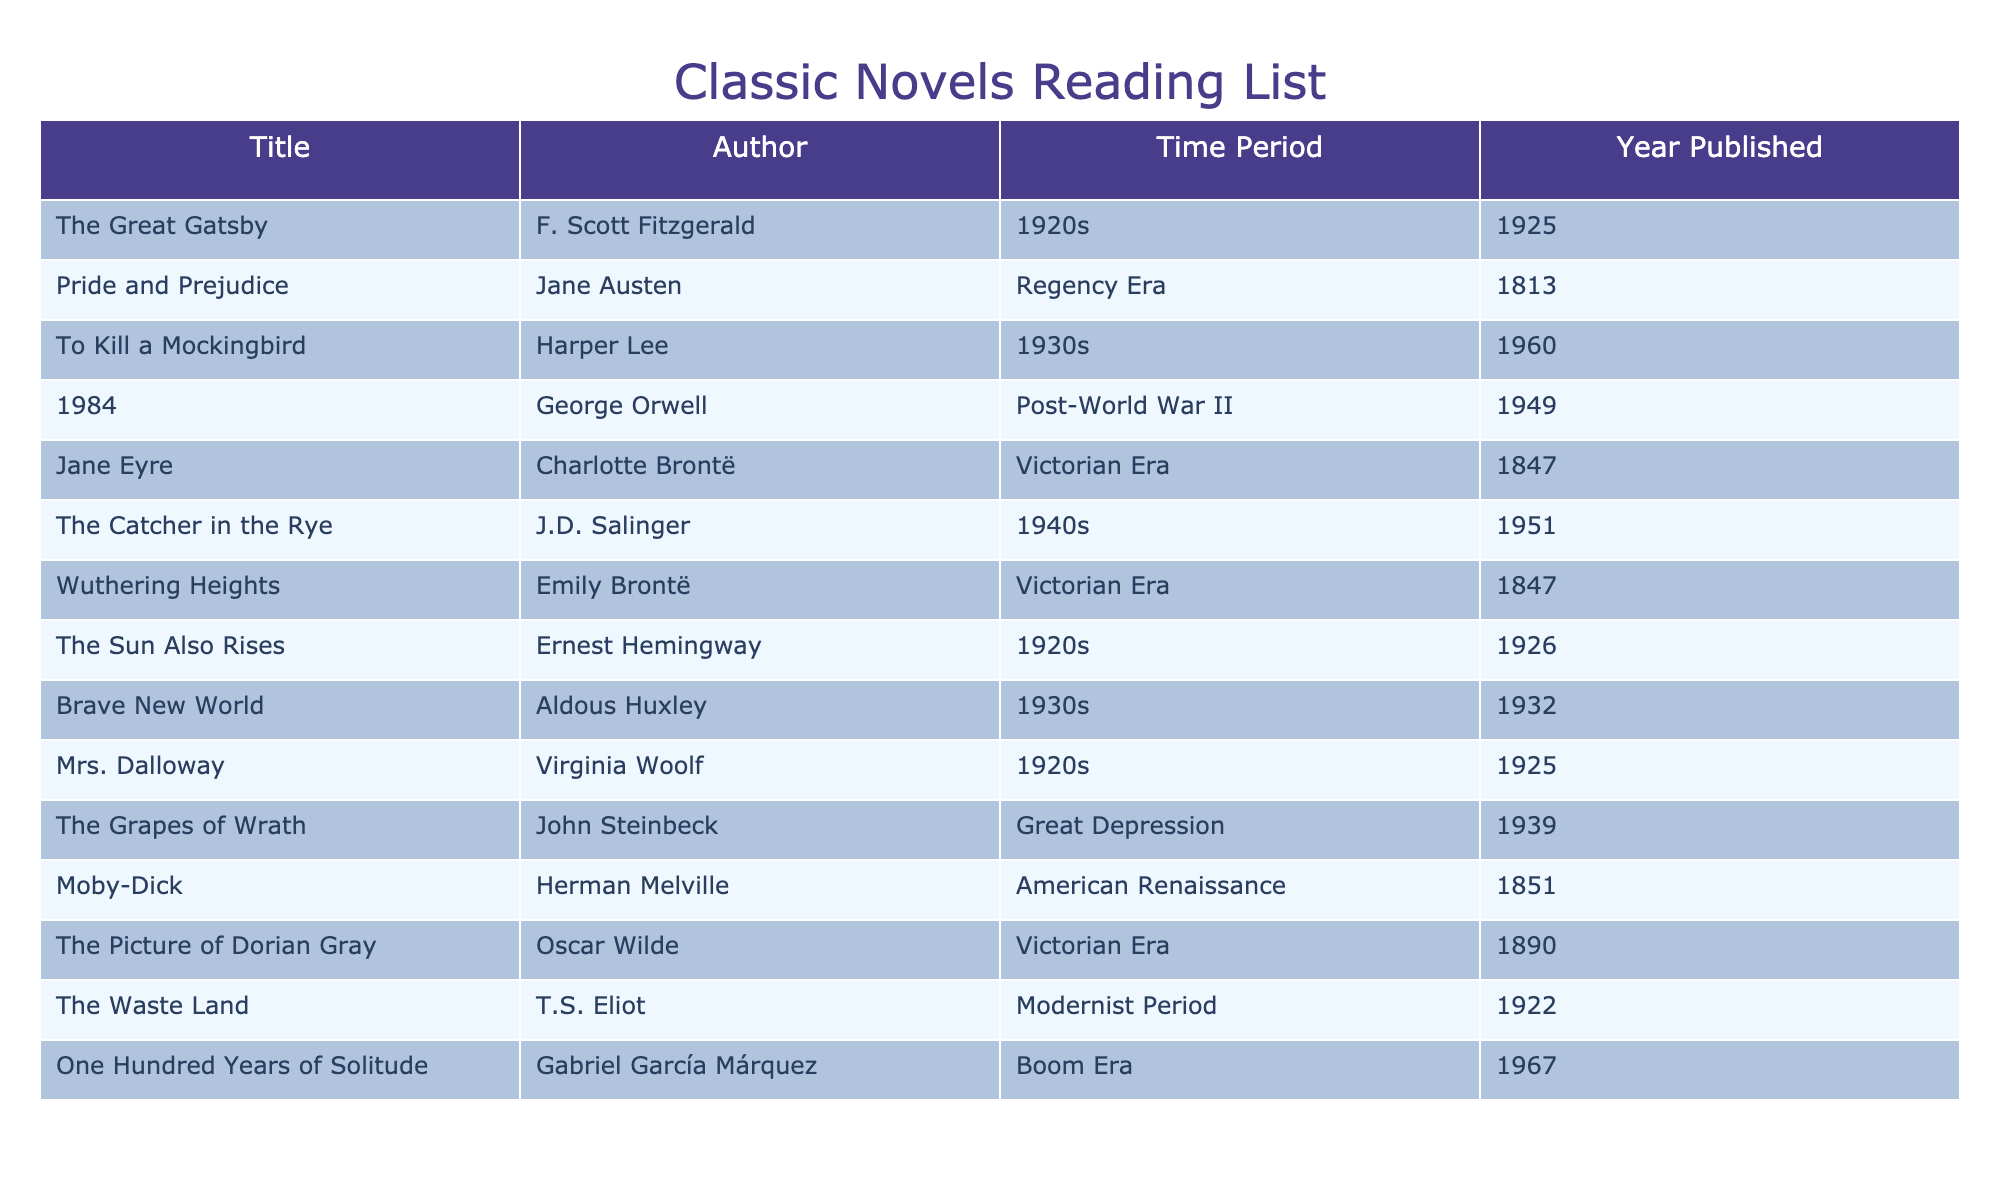What novels were published in the 1920s? The table lists three novels published in the 1920s: "The Great Gatsby" by F. Scott Fitzgerald in 1925, "The Sun Also Rises" by Ernest Hemingway in 1926, and "Mrs. Dalloway" by Virginia Woolf in 1925.
Answer: The Great Gatsby, The Sun Also Rises, Mrs. Dalloway Which author wrote "Pride and Prejudice"? The table indicates that "Pride and Prejudice" is written by Jane Austen.
Answer: Jane Austen Was "1984" published before "To Kill a Mockingbird"? The publication year of "1984" is 1949 and "To Kill a Mockingbird" in 1960; since 1949 is earlier than 1960, the statement is true.
Answer: Yes How many novels in the table are from the Victorian Era? The table lists "Jane Eyre," "Wuthering Heights," and "The Picture of Dorian Gray," so there are three novels from the Victorian Era.
Answer: 3 Which novel published in the 1930s has the earliest publication year? From the table, "Brave New World" was published in 1932, and "To Kill a Mockingbird" was published in 1960. Therefore, "Brave New World" has the earliest year of 1932.
Answer: Brave New World What is the time period of "The Grapes of Wrath"? The table states that "The Grapes of Wrath" by John Steinbeck is from the Great Depression time period.
Answer: Great Depression How many novels are attributed to the Modernist Period? From the table, only "The Waste Land" by T.S. Eliot is listed under the Modernist Period, thus only one novel is attributed to that period.
Answer: 1 Which author published the most novels in the table? The table lists unique novels by different authors without repetitions, so every author published one novel, but there are two by both Brontë sisters (Charlotte and Emily). Thus, the authors with the most novels are those two with each having one.
Answer: 2 Is "One Hundred Years of Solitude" the last novel listed in chronological order? "One Hundred Years of Solitude" was published in 1967, which is later than any other novel including "To Kill a Mockingbird" in 1960. Therefore, it is the last novel in the table.
Answer: Yes 